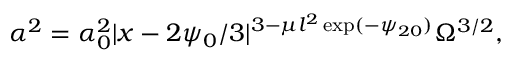<formula> <loc_0><loc_0><loc_500><loc_500>\alpha ^ { 2 } = \alpha _ { 0 } ^ { 2 } | x - 2 \psi _ { 0 } / 3 | ^ { 3 - \mu l ^ { 2 } \exp ( - \psi _ { 2 0 } ) } \Omega ^ { 3 / 2 } ,</formula> 